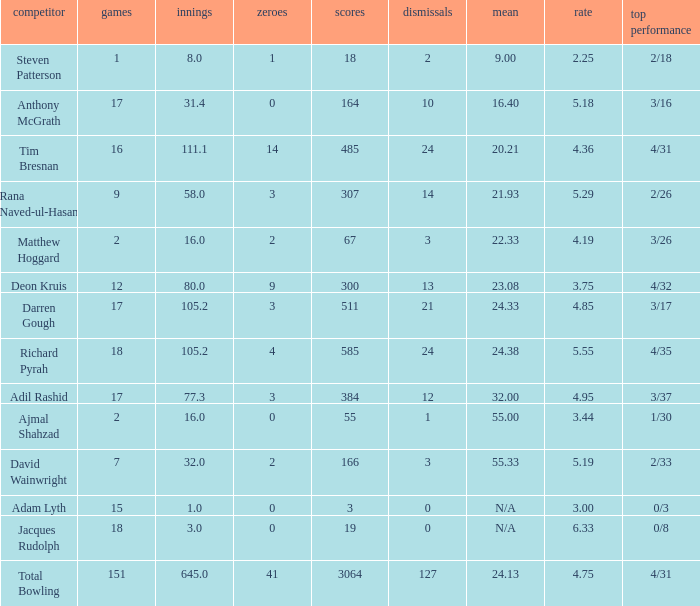What is the lowest Overs with a Run that is 18? 8.0. 